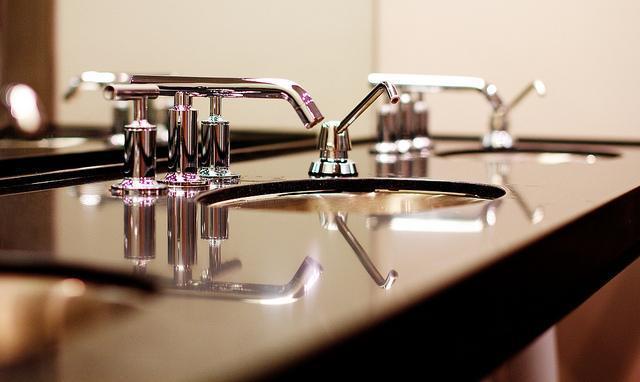How many sinks are displayed?
Give a very brief answer. 2. How many sinks can be seen?
Give a very brief answer. 2. How many cups do you see?
Give a very brief answer. 0. 